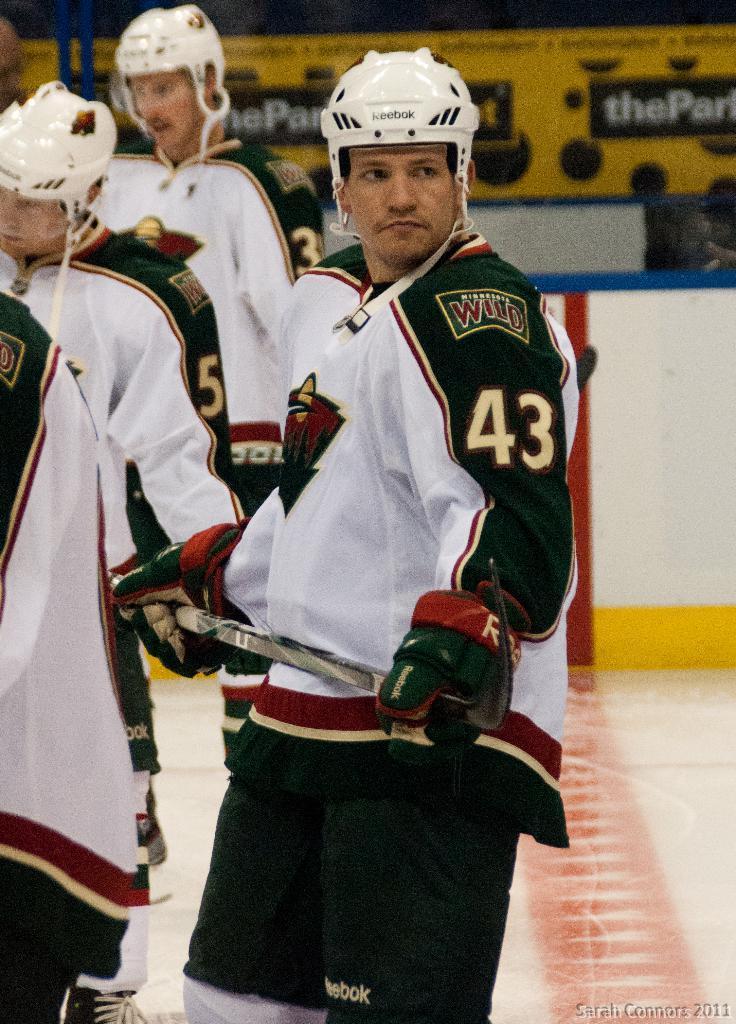In one or two sentences, can you explain what this image depicts? In this picture we can see a group of player standing and wearing white color t-shirt and black track holding the hockey stick in the hand. Behind there is a yellow color banner and small wall. 